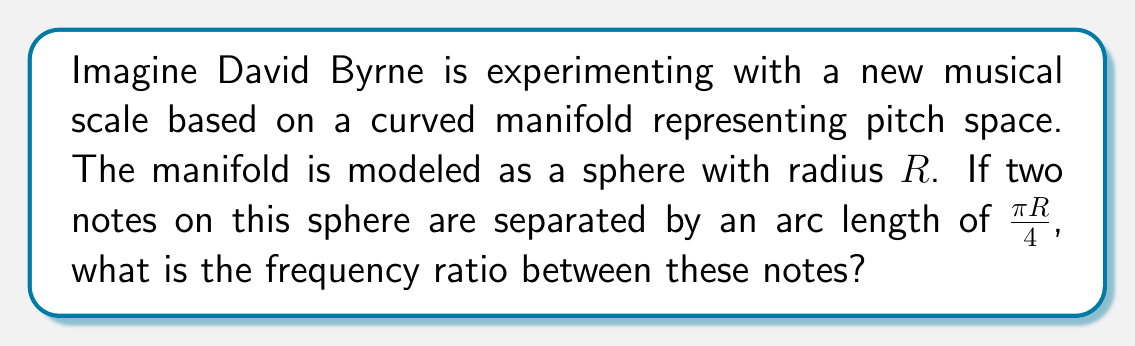Can you solve this math problem? To solve this problem, we need to understand how the curved manifold affects the relationship between arc length and frequency ratio. Let's approach this step-by-step:

1) In a standard linear pitch space, frequency ratios are exponentially related to pitch distances. The formula is:

   $$f_2 = f_1 \cdot 2^{\frac{d}{12}}$$

   where $f_1$ and $f_2$ are the frequencies, and $d$ is the number of semitones between them.

2) On our spherical manifold, we need to map the arc length to this linear scale. The full circumference of the sphere represents an octave (frequency ratio of 2:1).

3) The circumference of the sphere is $2\pi R$. So we can set up the proportion:

   $$\frac{\text{arc length}}{\text{circumference}} = \frac{\text{semitones}}{12}$$

4) Substituting our given arc length:

   $$\frac{\frac{\pi R}{4}}{2\pi R} = \frac{\text{semitones}}{12}$$

5) Simplifying:

   $$\frac{1}{8} = \frac{\text{semitones}}{12}$$

6) Solving for semitones:

   $$\text{semitones} = 12 \cdot \frac{1}{8} = \frac{3}{2}$$

7) Now we can use this in our frequency ratio formula:

   $$f_2 = f_1 \cdot 2^{\frac{3/2}{12}} = f_1 \cdot 2^{\frac{1}{8}}$$

8) To simplify this, we can use the properties of exponents:

   $$f_2 = f_1 \cdot \sqrt[8]{2}$$

Therefore, the frequency ratio is $1 : \sqrt[8]{2}$.
Answer: The frequency ratio between the two notes is $1 : \sqrt[8]{2}$. 